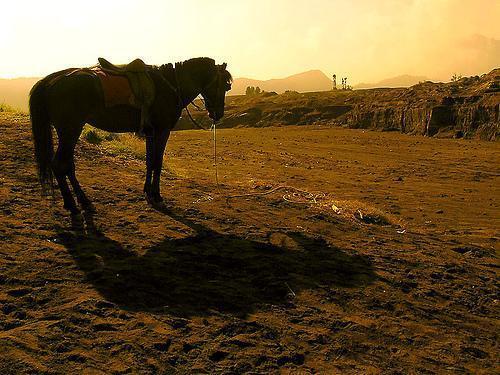How many horses are pictured?
Give a very brief answer. 1. How many horses are pictured?
Give a very brief answer. 1. 